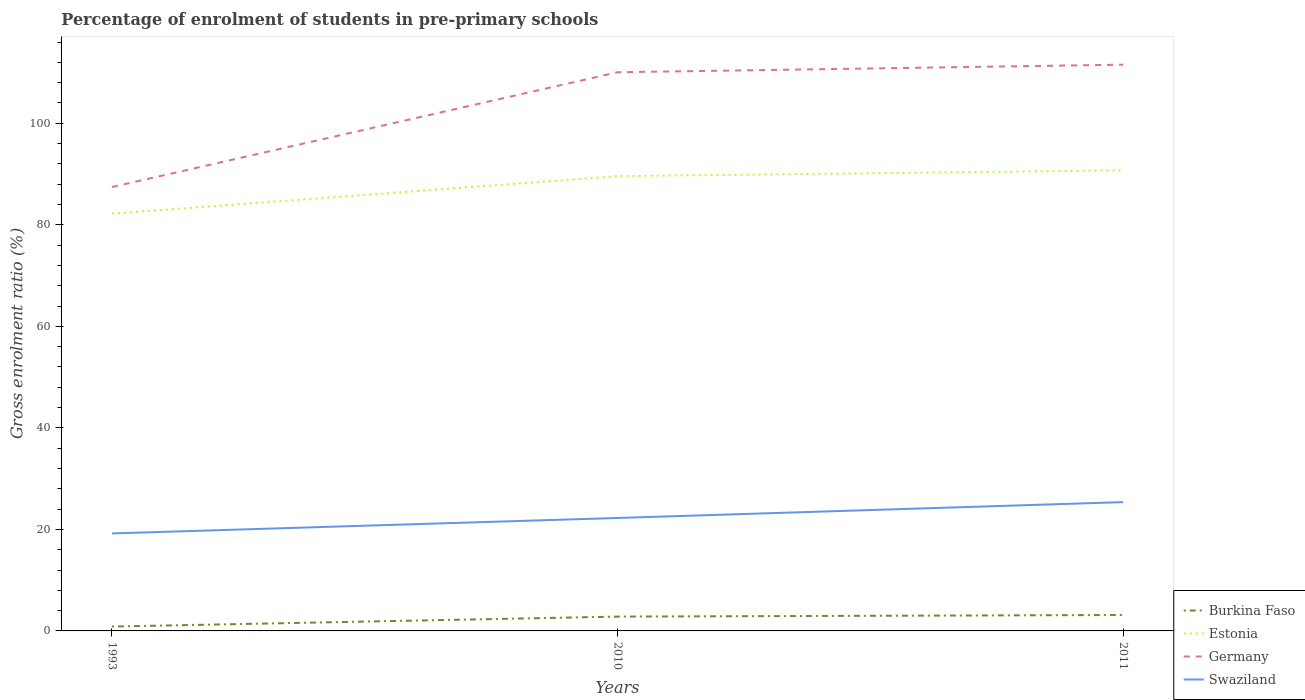How many different coloured lines are there?
Keep it short and to the point. 4. Across all years, what is the maximum percentage of students enrolled in pre-primary schools in Germany?
Your response must be concise. 87.45. In which year was the percentage of students enrolled in pre-primary schools in Germany maximum?
Give a very brief answer. 1993. What is the total percentage of students enrolled in pre-primary schools in Germany in the graph?
Make the answer very short. -1.49. What is the difference between the highest and the second highest percentage of students enrolled in pre-primary schools in Burkina Faso?
Provide a succinct answer. 2.28. What is the difference between the highest and the lowest percentage of students enrolled in pre-primary schools in Swaziland?
Your response must be concise. 1. What is the difference between two consecutive major ticks on the Y-axis?
Ensure brevity in your answer.  20. Does the graph contain any zero values?
Make the answer very short. No. Does the graph contain grids?
Offer a very short reply. No. Where does the legend appear in the graph?
Offer a very short reply. Bottom right. How are the legend labels stacked?
Offer a terse response. Vertical. What is the title of the graph?
Offer a very short reply. Percentage of enrolment of students in pre-primary schools. Does "Tuvalu" appear as one of the legend labels in the graph?
Your answer should be compact. No. What is the Gross enrolment ratio (%) in Burkina Faso in 1993?
Ensure brevity in your answer.  0.86. What is the Gross enrolment ratio (%) in Estonia in 1993?
Offer a very short reply. 82.2. What is the Gross enrolment ratio (%) of Germany in 1993?
Make the answer very short. 87.45. What is the Gross enrolment ratio (%) in Swaziland in 1993?
Keep it short and to the point. 19.21. What is the Gross enrolment ratio (%) in Burkina Faso in 2010?
Your answer should be compact. 2.82. What is the Gross enrolment ratio (%) in Estonia in 2010?
Give a very brief answer. 89.59. What is the Gross enrolment ratio (%) of Germany in 2010?
Give a very brief answer. 110.06. What is the Gross enrolment ratio (%) in Swaziland in 2010?
Provide a short and direct response. 22.25. What is the Gross enrolment ratio (%) of Burkina Faso in 2011?
Make the answer very short. 3.14. What is the Gross enrolment ratio (%) in Estonia in 2011?
Your answer should be very brief. 90.74. What is the Gross enrolment ratio (%) of Germany in 2011?
Provide a short and direct response. 111.55. What is the Gross enrolment ratio (%) in Swaziland in 2011?
Keep it short and to the point. 25.38. Across all years, what is the maximum Gross enrolment ratio (%) of Burkina Faso?
Your answer should be compact. 3.14. Across all years, what is the maximum Gross enrolment ratio (%) of Estonia?
Keep it short and to the point. 90.74. Across all years, what is the maximum Gross enrolment ratio (%) in Germany?
Make the answer very short. 111.55. Across all years, what is the maximum Gross enrolment ratio (%) in Swaziland?
Keep it short and to the point. 25.38. Across all years, what is the minimum Gross enrolment ratio (%) of Burkina Faso?
Give a very brief answer. 0.86. Across all years, what is the minimum Gross enrolment ratio (%) of Estonia?
Keep it short and to the point. 82.2. Across all years, what is the minimum Gross enrolment ratio (%) of Germany?
Your response must be concise. 87.45. Across all years, what is the minimum Gross enrolment ratio (%) in Swaziland?
Keep it short and to the point. 19.21. What is the total Gross enrolment ratio (%) in Burkina Faso in the graph?
Your answer should be very brief. 6.82. What is the total Gross enrolment ratio (%) in Estonia in the graph?
Keep it short and to the point. 262.53. What is the total Gross enrolment ratio (%) of Germany in the graph?
Offer a terse response. 309.06. What is the total Gross enrolment ratio (%) of Swaziland in the graph?
Provide a short and direct response. 66.83. What is the difference between the Gross enrolment ratio (%) in Burkina Faso in 1993 and that in 2010?
Your answer should be compact. -1.96. What is the difference between the Gross enrolment ratio (%) of Estonia in 1993 and that in 2010?
Provide a succinct answer. -7.39. What is the difference between the Gross enrolment ratio (%) in Germany in 1993 and that in 2010?
Offer a terse response. -22.61. What is the difference between the Gross enrolment ratio (%) of Swaziland in 1993 and that in 2010?
Ensure brevity in your answer.  -3.05. What is the difference between the Gross enrolment ratio (%) of Burkina Faso in 1993 and that in 2011?
Give a very brief answer. -2.28. What is the difference between the Gross enrolment ratio (%) in Estonia in 1993 and that in 2011?
Offer a very short reply. -8.53. What is the difference between the Gross enrolment ratio (%) of Germany in 1993 and that in 2011?
Offer a terse response. -24.1. What is the difference between the Gross enrolment ratio (%) of Swaziland in 1993 and that in 2011?
Make the answer very short. -6.17. What is the difference between the Gross enrolment ratio (%) of Burkina Faso in 2010 and that in 2011?
Keep it short and to the point. -0.31. What is the difference between the Gross enrolment ratio (%) in Estonia in 2010 and that in 2011?
Your response must be concise. -1.14. What is the difference between the Gross enrolment ratio (%) in Germany in 2010 and that in 2011?
Your answer should be compact. -1.49. What is the difference between the Gross enrolment ratio (%) of Swaziland in 2010 and that in 2011?
Make the answer very short. -3.12. What is the difference between the Gross enrolment ratio (%) in Burkina Faso in 1993 and the Gross enrolment ratio (%) in Estonia in 2010?
Offer a terse response. -88.73. What is the difference between the Gross enrolment ratio (%) in Burkina Faso in 1993 and the Gross enrolment ratio (%) in Germany in 2010?
Offer a terse response. -109.2. What is the difference between the Gross enrolment ratio (%) in Burkina Faso in 1993 and the Gross enrolment ratio (%) in Swaziland in 2010?
Keep it short and to the point. -21.39. What is the difference between the Gross enrolment ratio (%) of Estonia in 1993 and the Gross enrolment ratio (%) of Germany in 2010?
Your response must be concise. -27.85. What is the difference between the Gross enrolment ratio (%) in Estonia in 1993 and the Gross enrolment ratio (%) in Swaziland in 2010?
Give a very brief answer. 59.95. What is the difference between the Gross enrolment ratio (%) in Germany in 1993 and the Gross enrolment ratio (%) in Swaziland in 2010?
Ensure brevity in your answer.  65.2. What is the difference between the Gross enrolment ratio (%) in Burkina Faso in 1993 and the Gross enrolment ratio (%) in Estonia in 2011?
Offer a terse response. -89.88. What is the difference between the Gross enrolment ratio (%) in Burkina Faso in 1993 and the Gross enrolment ratio (%) in Germany in 2011?
Ensure brevity in your answer.  -110.69. What is the difference between the Gross enrolment ratio (%) in Burkina Faso in 1993 and the Gross enrolment ratio (%) in Swaziland in 2011?
Ensure brevity in your answer.  -24.52. What is the difference between the Gross enrolment ratio (%) in Estonia in 1993 and the Gross enrolment ratio (%) in Germany in 2011?
Provide a succinct answer. -29.35. What is the difference between the Gross enrolment ratio (%) of Estonia in 1993 and the Gross enrolment ratio (%) of Swaziland in 2011?
Offer a very short reply. 56.83. What is the difference between the Gross enrolment ratio (%) of Germany in 1993 and the Gross enrolment ratio (%) of Swaziland in 2011?
Your response must be concise. 62.07. What is the difference between the Gross enrolment ratio (%) of Burkina Faso in 2010 and the Gross enrolment ratio (%) of Estonia in 2011?
Provide a short and direct response. -87.92. What is the difference between the Gross enrolment ratio (%) of Burkina Faso in 2010 and the Gross enrolment ratio (%) of Germany in 2011?
Provide a short and direct response. -108.73. What is the difference between the Gross enrolment ratio (%) in Burkina Faso in 2010 and the Gross enrolment ratio (%) in Swaziland in 2011?
Ensure brevity in your answer.  -22.55. What is the difference between the Gross enrolment ratio (%) of Estonia in 2010 and the Gross enrolment ratio (%) of Germany in 2011?
Offer a very short reply. -21.96. What is the difference between the Gross enrolment ratio (%) of Estonia in 2010 and the Gross enrolment ratio (%) of Swaziland in 2011?
Make the answer very short. 64.22. What is the difference between the Gross enrolment ratio (%) of Germany in 2010 and the Gross enrolment ratio (%) of Swaziland in 2011?
Ensure brevity in your answer.  84.68. What is the average Gross enrolment ratio (%) of Burkina Faso per year?
Your answer should be compact. 2.27. What is the average Gross enrolment ratio (%) in Estonia per year?
Keep it short and to the point. 87.51. What is the average Gross enrolment ratio (%) in Germany per year?
Offer a terse response. 103.02. What is the average Gross enrolment ratio (%) of Swaziland per year?
Provide a short and direct response. 22.28. In the year 1993, what is the difference between the Gross enrolment ratio (%) in Burkina Faso and Gross enrolment ratio (%) in Estonia?
Offer a terse response. -81.35. In the year 1993, what is the difference between the Gross enrolment ratio (%) in Burkina Faso and Gross enrolment ratio (%) in Germany?
Make the answer very short. -86.59. In the year 1993, what is the difference between the Gross enrolment ratio (%) in Burkina Faso and Gross enrolment ratio (%) in Swaziland?
Offer a terse response. -18.35. In the year 1993, what is the difference between the Gross enrolment ratio (%) in Estonia and Gross enrolment ratio (%) in Germany?
Your response must be concise. -5.24. In the year 1993, what is the difference between the Gross enrolment ratio (%) in Estonia and Gross enrolment ratio (%) in Swaziland?
Your response must be concise. 63. In the year 1993, what is the difference between the Gross enrolment ratio (%) in Germany and Gross enrolment ratio (%) in Swaziland?
Ensure brevity in your answer.  68.24. In the year 2010, what is the difference between the Gross enrolment ratio (%) in Burkina Faso and Gross enrolment ratio (%) in Estonia?
Provide a short and direct response. -86.77. In the year 2010, what is the difference between the Gross enrolment ratio (%) of Burkina Faso and Gross enrolment ratio (%) of Germany?
Ensure brevity in your answer.  -107.24. In the year 2010, what is the difference between the Gross enrolment ratio (%) in Burkina Faso and Gross enrolment ratio (%) in Swaziland?
Ensure brevity in your answer.  -19.43. In the year 2010, what is the difference between the Gross enrolment ratio (%) of Estonia and Gross enrolment ratio (%) of Germany?
Ensure brevity in your answer.  -20.47. In the year 2010, what is the difference between the Gross enrolment ratio (%) in Estonia and Gross enrolment ratio (%) in Swaziland?
Give a very brief answer. 67.34. In the year 2010, what is the difference between the Gross enrolment ratio (%) of Germany and Gross enrolment ratio (%) of Swaziland?
Make the answer very short. 87.81. In the year 2011, what is the difference between the Gross enrolment ratio (%) in Burkina Faso and Gross enrolment ratio (%) in Estonia?
Provide a succinct answer. -87.6. In the year 2011, what is the difference between the Gross enrolment ratio (%) of Burkina Faso and Gross enrolment ratio (%) of Germany?
Your response must be concise. -108.41. In the year 2011, what is the difference between the Gross enrolment ratio (%) in Burkina Faso and Gross enrolment ratio (%) in Swaziland?
Keep it short and to the point. -22.24. In the year 2011, what is the difference between the Gross enrolment ratio (%) of Estonia and Gross enrolment ratio (%) of Germany?
Your answer should be very brief. -20.81. In the year 2011, what is the difference between the Gross enrolment ratio (%) of Estonia and Gross enrolment ratio (%) of Swaziland?
Offer a terse response. 65.36. In the year 2011, what is the difference between the Gross enrolment ratio (%) of Germany and Gross enrolment ratio (%) of Swaziland?
Offer a terse response. 86.18. What is the ratio of the Gross enrolment ratio (%) of Burkina Faso in 1993 to that in 2010?
Make the answer very short. 0.3. What is the ratio of the Gross enrolment ratio (%) of Estonia in 1993 to that in 2010?
Ensure brevity in your answer.  0.92. What is the ratio of the Gross enrolment ratio (%) in Germany in 1993 to that in 2010?
Provide a short and direct response. 0.79. What is the ratio of the Gross enrolment ratio (%) of Swaziland in 1993 to that in 2010?
Keep it short and to the point. 0.86. What is the ratio of the Gross enrolment ratio (%) of Burkina Faso in 1993 to that in 2011?
Your answer should be very brief. 0.27. What is the ratio of the Gross enrolment ratio (%) of Estonia in 1993 to that in 2011?
Offer a terse response. 0.91. What is the ratio of the Gross enrolment ratio (%) in Germany in 1993 to that in 2011?
Provide a short and direct response. 0.78. What is the ratio of the Gross enrolment ratio (%) of Swaziland in 1993 to that in 2011?
Offer a terse response. 0.76. What is the ratio of the Gross enrolment ratio (%) of Burkina Faso in 2010 to that in 2011?
Ensure brevity in your answer.  0.9. What is the ratio of the Gross enrolment ratio (%) in Estonia in 2010 to that in 2011?
Make the answer very short. 0.99. What is the ratio of the Gross enrolment ratio (%) of Germany in 2010 to that in 2011?
Offer a terse response. 0.99. What is the ratio of the Gross enrolment ratio (%) of Swaziland in 2010 to that in 2011?
Offer a terse response. 0.88. What is the difference between the highest and the second highest Gross enrolment ratio (%) in Burkina Faso?
Keep it short and to the point. 0.31. What is the difference between the highest and the second highest Gross enrolment ratio (%) of Estonia?
Provide a short and direct response. 1.14. What is the difference between the highest and the second highest Gross enrolment ratio (%) in Germany?
Offer a very short reply. 1.49. What is the difference between the highest and the second highest Gross enrolment ratio (%) of Swaziland?
Make the answer very short. 3.12. What is the difference between the highest and the lowest Gross enrolment ratio (%) of Burkina Faso?
Offer a terse response. 2.28. What is the difference between the highest and the lowest Gross enrolment ratio (%) in Estonia?
Offer a terse response. 8.53. What is the difference between the highest and the lowest Gross enrolment ratio (%) of Germany?
Give a very brief answer. 24.1. What is the difference between the highest and the lowest Gross enrolment ratio (%) in Swaziland?
Provide a short and direct response. 6.17. 